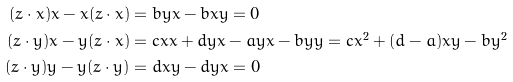Convert formula to latex. <formula><loc_0><loc_0><loc_500><loc_500>( z \cdot x ) x - x ( z \cdot x ) & = b y x - b x y = 0 \\ ( z \cdot y ) x - y ( z \cdot x ) & = c x x + d y x - a y x - b y y = c x ^ { 2 } + ( d - a ) x y - b y ^ { 2 } \\ ( z \cdot y ) y - y ( z \cdot y ) & = d x y - d y x = 0</formula> 